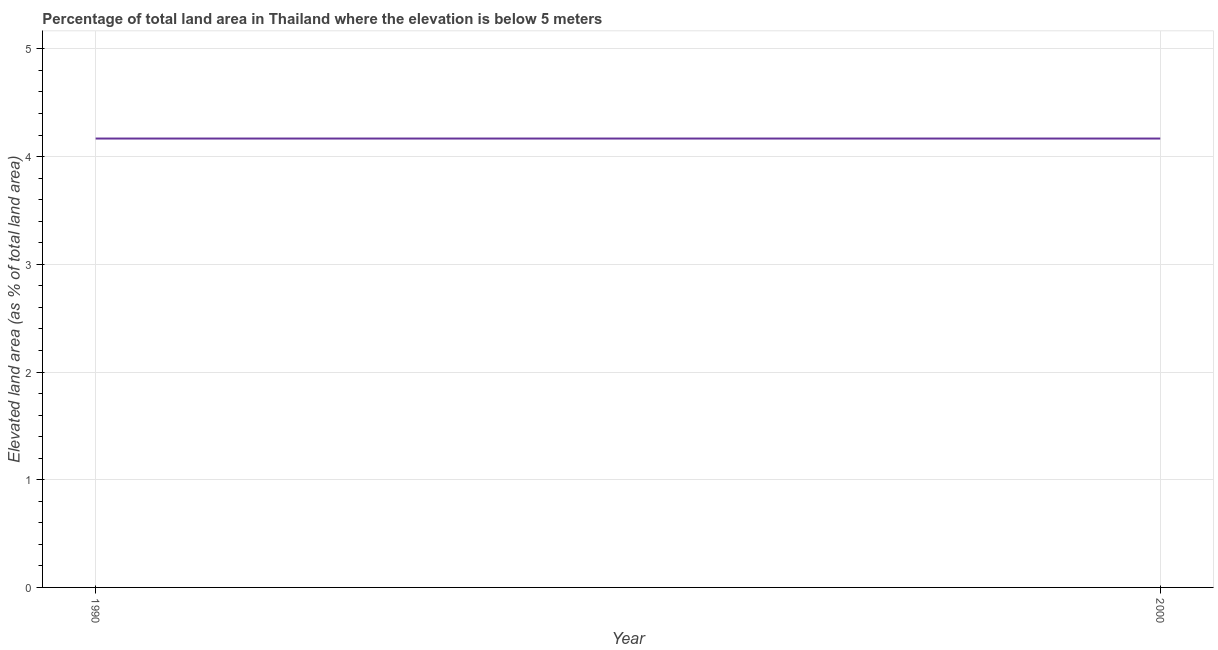What is the total elevated land area in 2000?
Your response must be concise. 4.17. Across all years, what is the maximum total elevated land area?
Offer a very short reply. 4.17. Across all years, what is the minimum total elevated land area?
Give a very brief answer. 4.17. In which year was the total elevated land area minimum?
Offer a terse response. 1990. What is the sum of the total elevated land area?
Provide a succinct answer. 8.34. What is the average total elevated land area per year?
Your answer should be very brief. 4.17. What is the median total elevated land area?
Give a very brief answer. 4.17. Do a majority of the years between 1990 and 2000 (inclusive) have total elevated land area greater than 0.6000000000000001 %?
Offer a terse response. Yes. Is the total elevated land area in 1990 less than that in 2000?
Provide a succinct answer. No. Does the total elevated land area monotonically increase over the years?
Offer a very short reply. No. How many lines are there?
Give a very brief answer. 1. What is the difference between two consecutive major ticks on the Y-axis?
Your answer should be compact. 1. What is the title of the graph?
Offer a terse response. Percentage of total land area in Thailand where the elevation is below 5 meters. What is the label or title of the Y-axis?
Give a very brief answer. Elevated land area (as % of total land area). What is the Elevated land area (as % of total land area) in 1990?
Your answer should be very brief. 4.17. What is the Elevated land area (as % of total land area) in 2000?
Make the answer very short. 4.17. What is the difference between the Elevated land area (as % of total land area) in 1990 and 2000?
Offer a terse response. 0. 